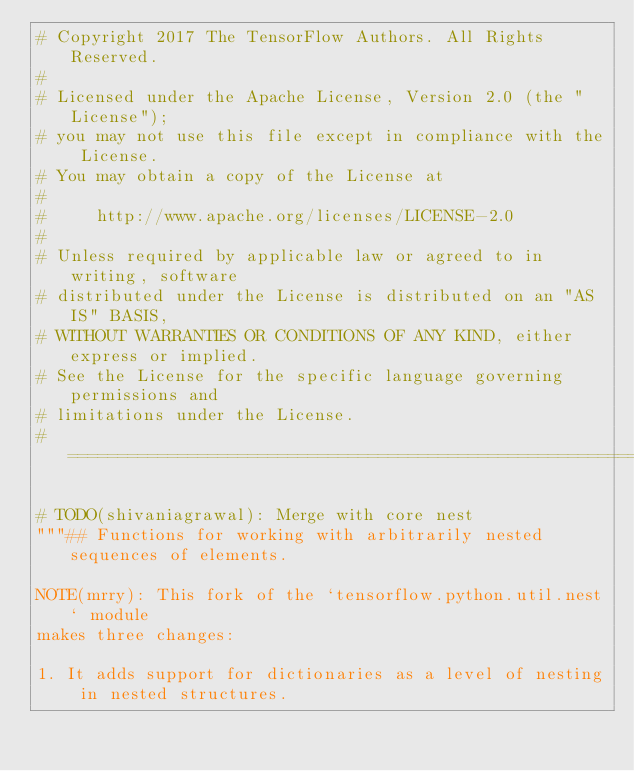<code> <loc_0><loc_0><loc_500><loc_500><_Python_># Copyright 2017 The TensorFlow Authors. All Rights Reserved.
#
# Licensed under the Apache License, Version 2.0 (the "License");
# you may not use this file except in compliance with the License.
# You may obtain a copy of the License at
#
#     http://www.apache.org/licenses/LICENSE-2.0
#
# Unless required by applicable law or agreed to in writing, software
# distributed under the License is distributed on an "AS IS" BASIS,
# WITHOUT WARRANTIES OR CONDITIONS OF ANY KIND, either express or implied.
# See the License for the specific language governing permissions and
# limitations under the License.
# ==============================================================================

# TODO(shivaniagrawal): Merge with core nest
"""## Functions for working with arbitrarily nested sequences of elements.

NOTE(mrry): This fork of the `tensorflow.python.util.nest` module
makes three changes:

1. It adds support for dictionaries as a level of nesting in nested structures.</code> 